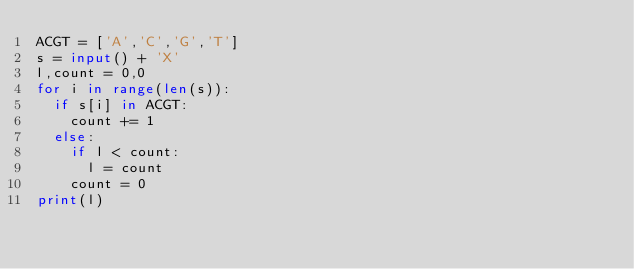<code> <loc_0><loc_0><loc_500><loc_500><_Python_>ACGT = ['A','C','G','T']
s = input() + 'X'
l,count = 0,0
for i in range(len(s)):
	if s[i] in ACGT:
		count += 1
	else:
		if l < count:
			l = count
		count = 0
print(l)</code> 